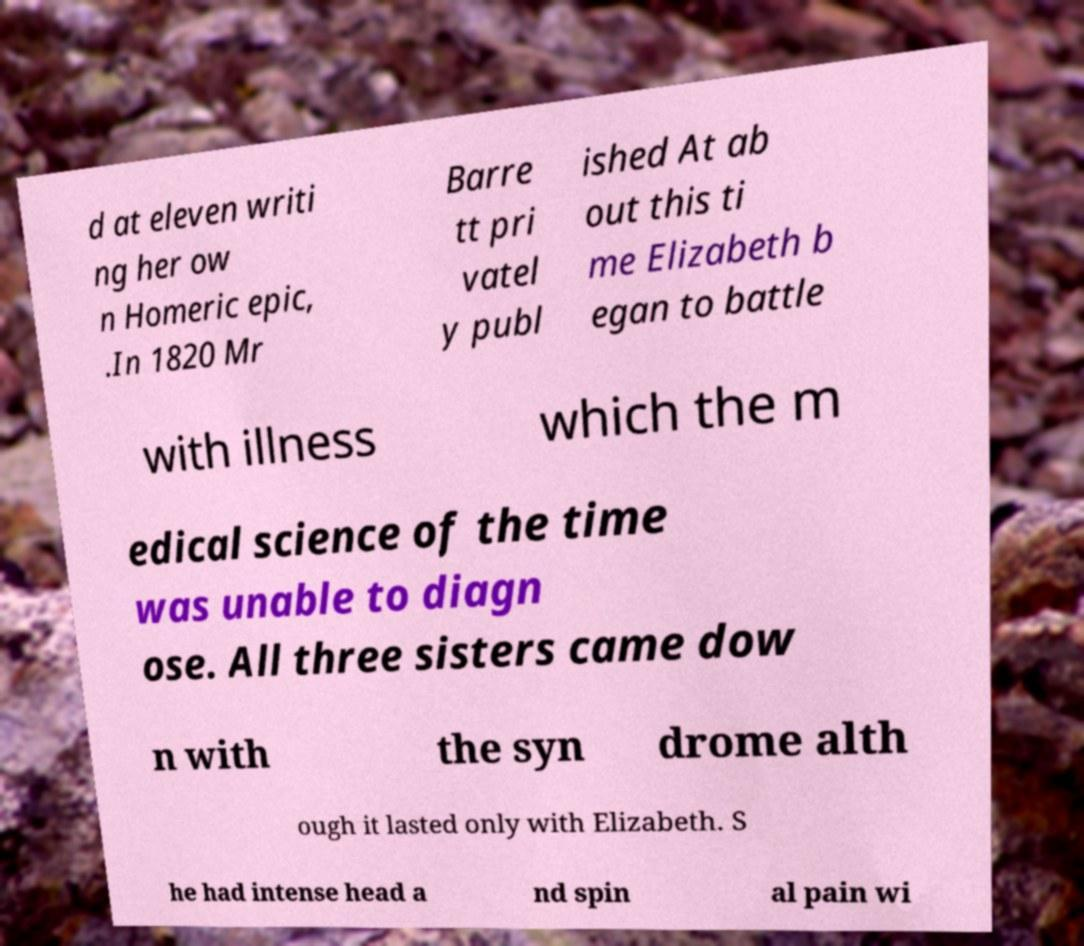Could you assist in decoding the text presented in this image and type it out clearly? d at eleven writi ng her ow n Homeric epic, .In 1820 Mr Barre tt pri vatel y publ ished At ab out this ti me Elizabeth b egan to battle with illness which the m edical science of the time was unable to diagn ose. All three sisters came dow n with the syn drome alth ough it lasted only with Elizabeth. S he had intense head a nd spin al pain wi 